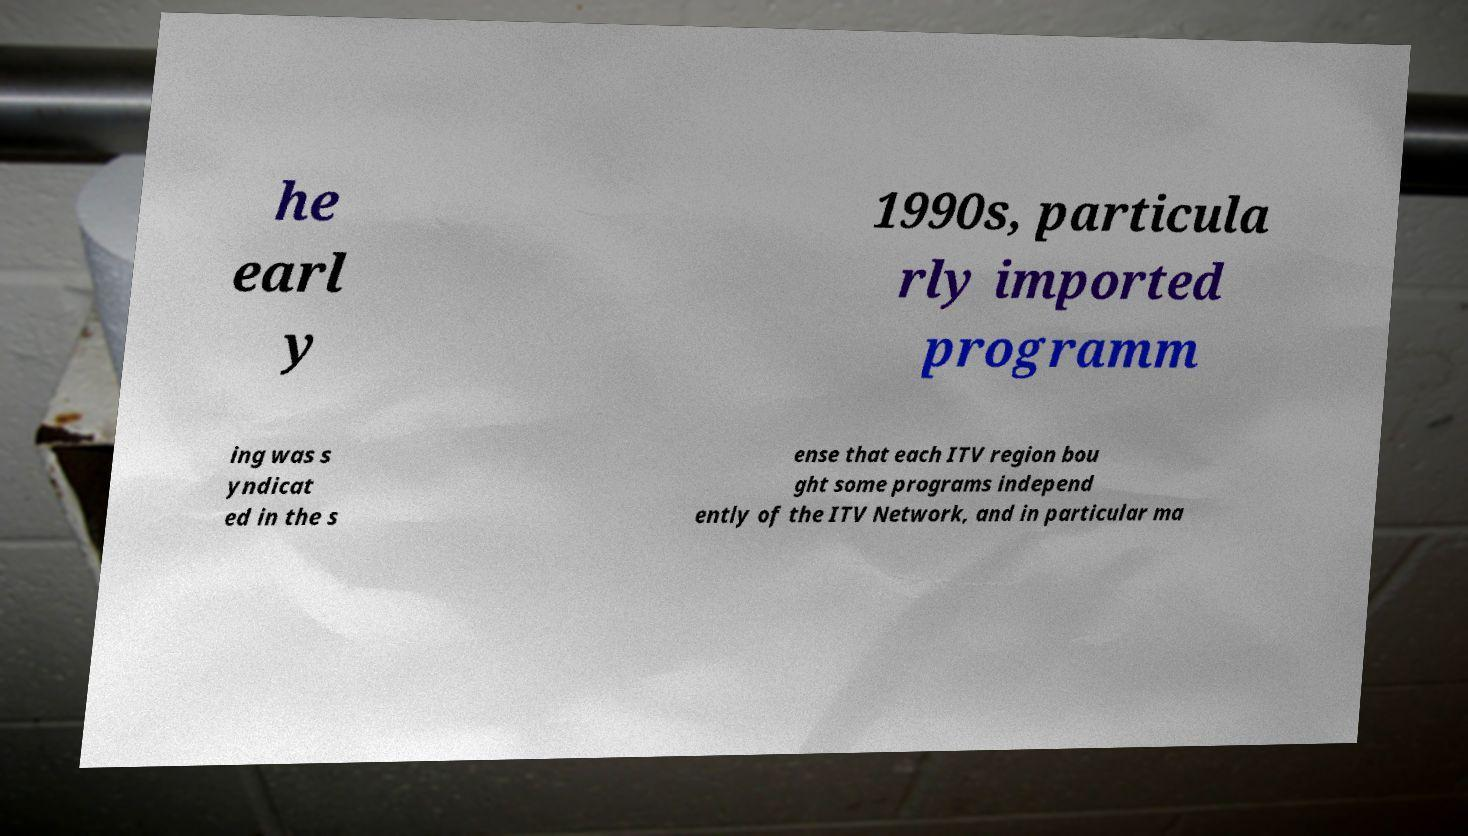I need the written content from this picture converted into text. Can you do that? he earl y 1990s, particula rly imported programm ing was s yndicat ed in the s ense that each ITV region bou ght some programs independ ently of the ITV Network, and in particular ma 